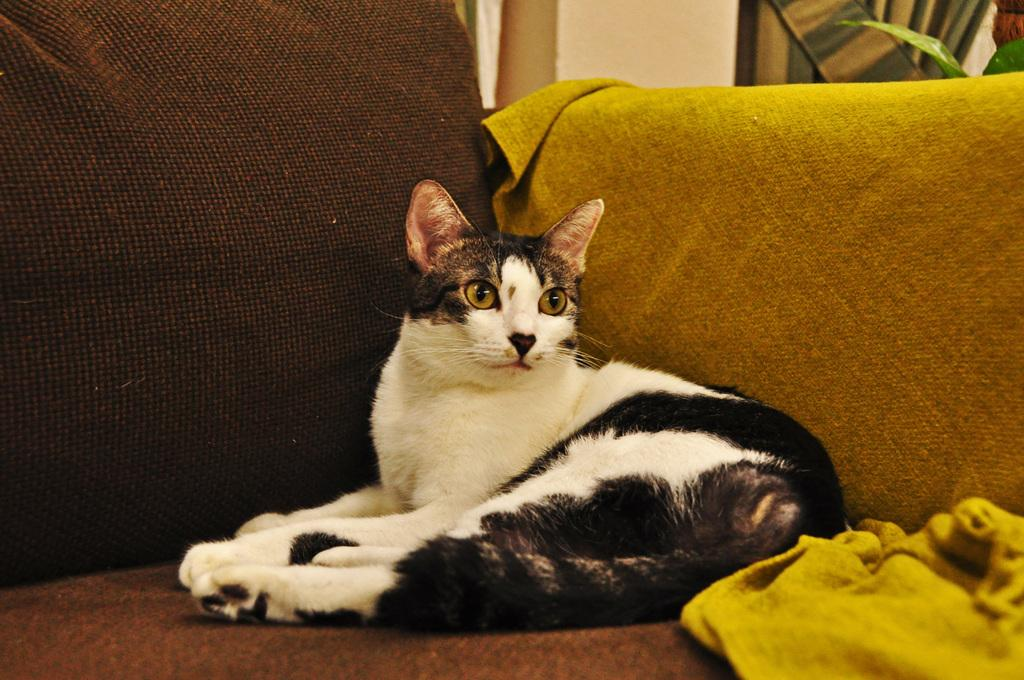What animal is sitting on the sofa in the image? There is a cat sitting on the sofa in the image. What else is on the sofa besides the cat? There are clothes on the sofa. Can you describe any other objects or elements in the image? There is a plant in the image. What can be seen in the background of the image? There is a wall in the background of the image. What type of mailbox is visible in the image? There is no mailbox present in the image. What is the title of the book the cat is reading on the sofa? There is no book or reading material visible in the image. 